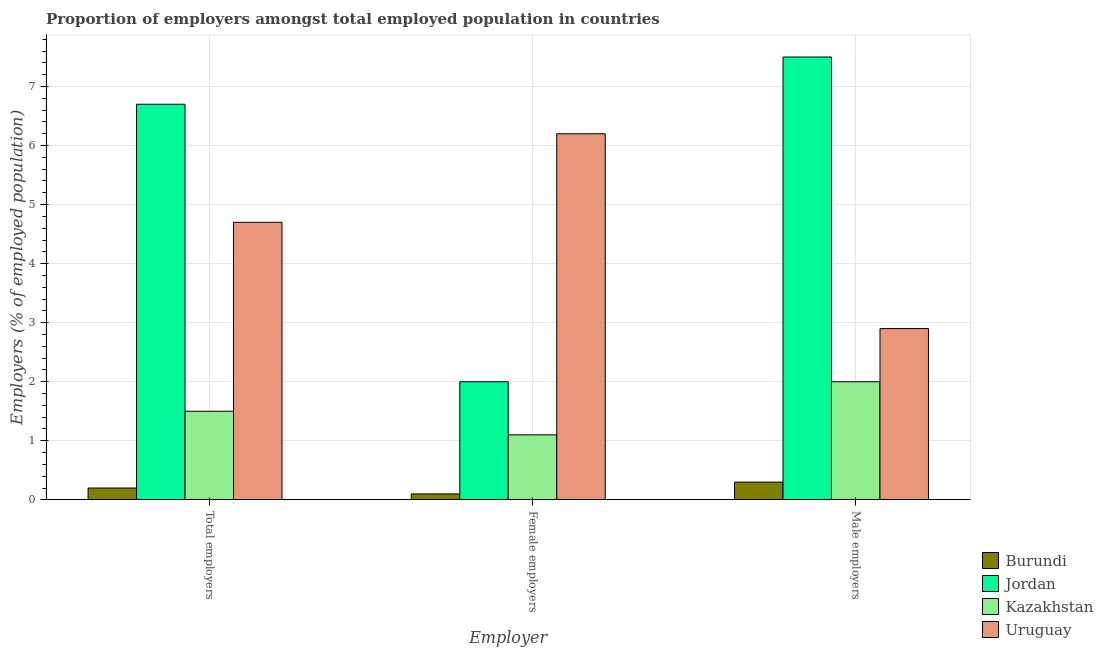How many different coloured bars are there?
Your answer should be compact. 4. How many groups of bars are there?
Offer a terse response. 3. Are the number of bars per tick equal to the number of legend labels?
Provide a succinct answer. Yes. How many bars are there on the 2nd tick from the left?
Offer a terse response. 4. What is the label of the 2nd group of bars from the left?
Provide a short and direct response. Female employers. What is the percentage of male employers in Burundi?
Provide a short and direct response. 0.3. Across all countries, what is the maximum percentage of total employers?
Give a very brief answer. 6.7. Across all countries, what is the minimum percentage of total employers?
Keep it short and to the point. 0.2. In which country was the percentage of female employers maximum?
Provide a short and direct response. Uruguay. In which country was the percentage of female employers minimum?
Your answer should be compact. Burundi. What is the total percentage of female employers in the graph?
Provide a short and direct response. 9.4. What is the difference between the percentage of total employers in Jordan and that in Burundi?
Your answer should be very brief. 6.5. What is the difference between the percentage of female employers in Uruguay and the percentage of male employers in Burundi?
Provide a succinct answer. 5.9. What is the average percentage of female employers per country?
Provide a short and direct response. 2.35. What is the difference between the percentage of female employers and percentage of male employers in Burundi?
Keep it short and to the point. -0.2. In how many countries, is the percentage of male employers greater than 7.6 %?
Provide a short and direct response. 0. What is the ratio of the percentage of male employers in Burundi to that in Kazakhstan?
Keep it short and to the point. 0.15. Is the percentage of male employers in Burundi less than that in Jordan?
Ensure brevity in your answer.  Yes. Is the difference between the percentage of male employers in Uruguay and Jordan greater than the difference between the percentage of female employers in Uruguay and Jordan?
Offer a very short reply. No. What is the difference between the highest and the second highest percentage of female employers?
Your answer should be very brief. 4.2. What is the difference between the highest and the lowest percentage of male employers?
Offer a terse response. 7.2. In how many countries, is the percentage of total employers greater than the average percentage of total employers taken over all countries?
Keep it short and to the point. 2. Is the sum of the percentage of male employers in Kazakhstan and Burundi greater than the maximum percentage of female employers across all countries?
Your answer should be very brief. No. What does the 4th bar from the left in Total employers represents?
Keep it short and to the point. Uruguay. What does the 2nd bar from the right in Total employers represents?
Provide a short and direct response. Kazakhstan. How many bars are there?
Your response must be concise. 12. How many countries are there in the graph?
Ensure brevity in your answer.  4. Are the values on the major ticks of Y-axis written in scientific E-notation?
Your answer should be compact. No. Does the graph contain grids?
Ensure brevity in your answer.  Yes. Where does the legend appear in the graph?
Your answer should be very brief. Bottom right. How many legend labels are there?
Make the answer very short. 4. What is the title of the graph?
Give a very brief answer. Proportion of employers amongst total employed population in countries. Does "Finland" appear as one of the legend labels in the graph?
Your answer should be very brief. No. What is the label or title of the X-axis?
Offer a very short reply. Employer. What is the label or title of the Y-axis?
Provide a short and direct response. Employers (% of employed population). What is the Employers (% of employed population) in Burundi in Total employers?
Make the answer very short. 0.2. What is the Employers (% of employed population) of Jordan in Total employers?
Provide a short and direct response. 6.7. What is the Employers (% of employed population) in Kazakhstan in Total employers?
Ensure brevity in your answer.  1.5. What is the Employers (% of employed population) of Uruguay in Total employers?
Your answer should be very brief. 4.7. What is the Employers (% of employed population) of Burundi in Female employers?
Offer a very short reply. 0.1. What is the Employers (% of employed population) of Jordan in Female employers?
Keep it short and to the point. 2. What is the Employers (% of employed population) in Kazakhstan in Female employers?
Your response must be concise. 1.1. What is the Employers (% of employed population) in Uruguay in Female employers?
Give a very brief answer. 6.2. What is the Employers (% of employed population) of Burundi in Male employers?
Offer a terse response. 0.3. What is the Employers (% of employed population) in Uruguay in Male employers?
Give a very brief answer. 2.9. Across all Employer, what is the maximum Employers (% of employed population) of Burundi?
Your answer should be compact. 0.3. Across all Employer, what is the maximum Employers (% of employed population) of Jordan?
Give a very brief answer. 7.5. Across all Employer, what is the maximum Employers (% of employed population) in Uruguay?
Your answer should be compact. 6.2. Across all Employer, what is the minimum Employers (% of employed population) of Burundi?
Give a very brief answer. 0.1. Across all Employer, what is the minimum Employers (% of employed population) in Kazakhstan?
Provide a succinct answer. 1.1. Across all Employer, what is the minimum Employers (% of employed population) of Uruguay?
Make the answer very short. 2.9. What is the total Employers (% of employed population) in Burundi in the graph?
Your response must be concise. 0.6. What is the difference between the Employers (% of employed population) in Uruguay in Total employers and that in Female employers?
Your answer should be very brief. -1.5. What is the difference between the Employers (% of employed population) in Jordan in Total employers and that in Male employers?
Offer a very short reply. -0.8. What is the difference between the Employers (% of employed population) in Kazakhstan in Total employers and that in Male employers?
Ensure brevity in your answer.  -0.5. What is the difference between the Employers (% of employed population) in Uruguay in Total employers and that in Male employers?
Provide a succinct answer. 1.8. What is the difference between the Employers (% of employed population) in Burundi in Total employers and the Employers (% of employed population) in Kazakhstan in Male employers?
Your answer should be very brief. -1.8. What is the difference between the Employers (% of employed population) in Jordan in Total employers and the Employers (% of employed population) in Kazakhstan in Male employers?
Give a very brief answer. 4.7. What is the difference between the Employers (% of employed population) of Jordan in Female employers and the Employers (% of employed population) of Kazakhstan in Male employers?
Make the answer very short. 0. What is the average Employers (% of employed population) in Burundi per Employer?
Offer a terse response. 0.2. What is the average Employers (% of employed population) in Kazakhstan per Employer?
Keep it short and to the point. 1.53. What is the difference between the Employers (% of employed population) in Burundi and Employers (% of employed population) in Jordan in Total employers?
Offer a terse response. -6.5. What is the difference between the Employers (% of employed population) in Burundi and Employers (% of employed population) in Kazakhstan in Total employers?
Keep it short and to the point. -1.3. What is the difference between the Employers (% of employed population) in Burundi and Employers (% of employed population) in Uruguay in Total employers?
Ensure brevity in your answer.  -4.5. What is the difference between the Employers (% of employed population) of Jordan and Employers (% of employed population) of Kazakhstan in Total employers?
Provide a succinct answer. 5.2. What is the difference between the Employers (% of employed population) of Jordan and Employers (% of employed population) of Uruguay in Total employers?
Provide a succinct answer. 2. What is the difference between the Employers (% of employed population) in Kazakhstan and Employers (% of employed population) in Uruguay in Total employers?
Ensure brevity in your answer.  -3.2. What is the difference between the Employers (% of employed population) in Burundi and Employers (% of employed population) in Kazakhstan in Female employers?
Offer a terse response. -1. What is the difference between the Employers (% of employed population) of Burundi and Employers (% of employed population) of Uruguay in Female employers?
Your answer should be compact. -6.1. What is the difference between the Employers (% of employed population) in Jordan and Employers (% of employed population) in Kazakhstan in Female employers?
Your response must be concise. 0.9. What is the difference between the Employers (% of employed population) of Kazakhstan and Employers (% of employed population) of Uruguay in Female employers?
Your answer should be very brief. -5.1. What is the difference between the Employers (% of employed population) of Burundi and Employers (% of employed population) of Kazakhstan in Male employers?
Ensure brevity in your answer.  -1.7. What is the difference between the Employers (% of employed population) of Jordan and Employers (% of employed population) of Kazakhstan in Male employers?
Your answer should be compact. 5.5. What is the ratio of the Employers (% of employed population) in Jordan in Total employers to that in Female employers?
Provide a short and direct response. 3.35. What is the ratio of the Employers (% of employed population) in Kazakhstan in Total employers to that in Female employers?
Provide a succinct answer. 1.36. What is the ratio of the Employers (% of employed population) of Uruguay in Total employers to that in Female employers?
Give a very brief answer. 0.76. What is the ratio of the Employers (% of employed population) in Jordan in Total employers to that in Male employers?
Provide a short and direct response. 0.89. What is the ratio of the Employers (% of employed population) of Uruguay in Total employers to that in Male employers?
Keep it short and to the point. 1.62. What is the ratio of the Employers (% of employed population) in Burundi in Female employers to that in Male employers?
Your answer should be very brief. 0.33. What is the ratio of the Employers (% of employed population) of Jordan in Female employers to that in Male employers?
Give a very brief answer. 0.27. What is the ratio of the Employers (% of employed population) of Kazakhstan in Female employers to that in Male employers?
Provide a succinct answer. 0.55. What is the ratio of the Employers (% of employed population) in Uruguay in Female employers to that in Male employers?
Ensure brevity in your answer.  2.14. What is the difference between the highest and the second highest Employers (% of employed population) of Jordan?
Make the answer very short. 0.8. What is the difference between the highest and the second highest Employers (% of employed population) of Uruguay?
Make the answer very short. 1.5. What is the difference between the highest and the lowest Employers (% of employed population) in Burundi?
Ensure brevity in your answer.  0.2. What is the difference between the highest and the lowest Employers (% of employed population) of Jordan?
Keep it short and to the point. 5.5. What is the difference between the highest and the lowest Employers (% of employed population) of Uruguay?
Give a very brief answer. 3.3. 